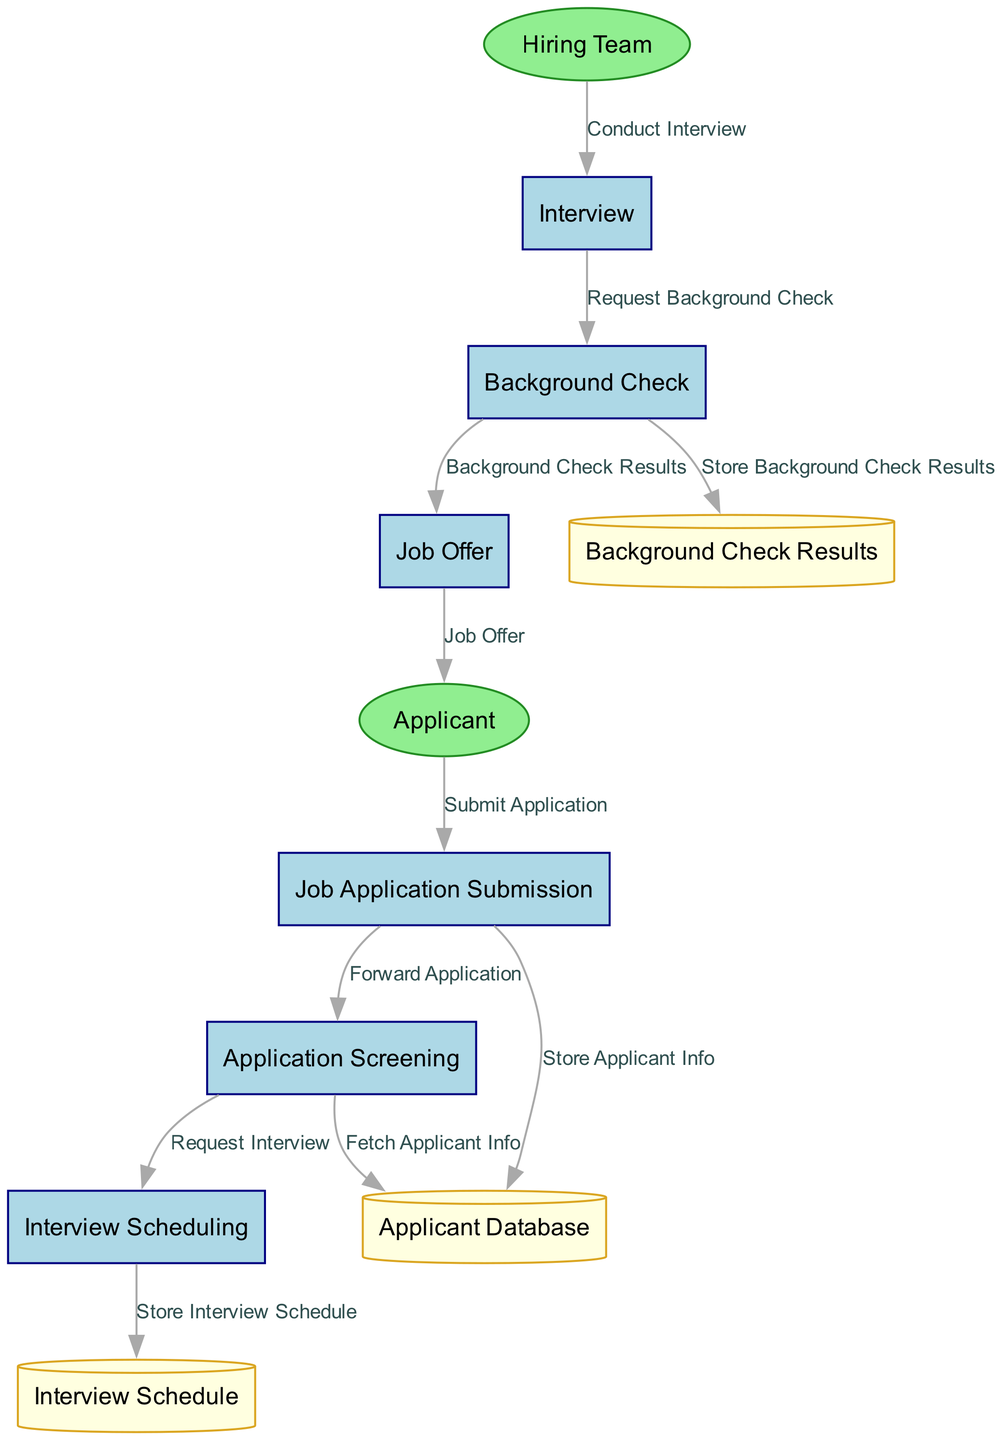What is the first process in the diagram? The diagram describes sequential processes, starting with "Job Application Submission" as the first step.
Answer: Job Application Submission How many processes are listed in the diagram? There are six processes identified in the diagram, from job application submission to job offer.
Answer: Six What does the applicant submit? According to the data flow, the applicant submits a "job application" as their initial action in the process.
Answer: Job application Which entity conducts the interview? The diagram indicates that the "Hiring Team" is responsible for conducting interviews with the applicants.
Answer: Hiring Team What is the purpose of the "Background Check"? The "Background Check" is undertaken to verify the applicant's information and is especially important for law enforcement-related jobs.
Answer: Verify information What happens to the background check results after they are available? The background check results are stored in the "Background Check Results" data store and then used to decide on the job offer.
Answer: Stored and used for the job decision How is the interview scheduled? The "Interview Scheduling" process creates the schedule, which is then stored in the "Interview Schedule" data store.
Answer: Through Interview Scheduling What type of data store is the "Applicant Database"? The "Applicant Database" is categorized as a data store, specifically a cylinder shape, indicating it contains permanent data storage for applicant information.
Answer: Data store Which process directly follows the completion of the interview? After the interview process is completed, the next step is the "Background Check," which indicates the need for verification.
Answer: Background Check What is the final output of this diagram? The final output of the process is the "Job Offer," which indicates that the applicant has been selected for employment after all prior steps.
Answer: Job Offer 